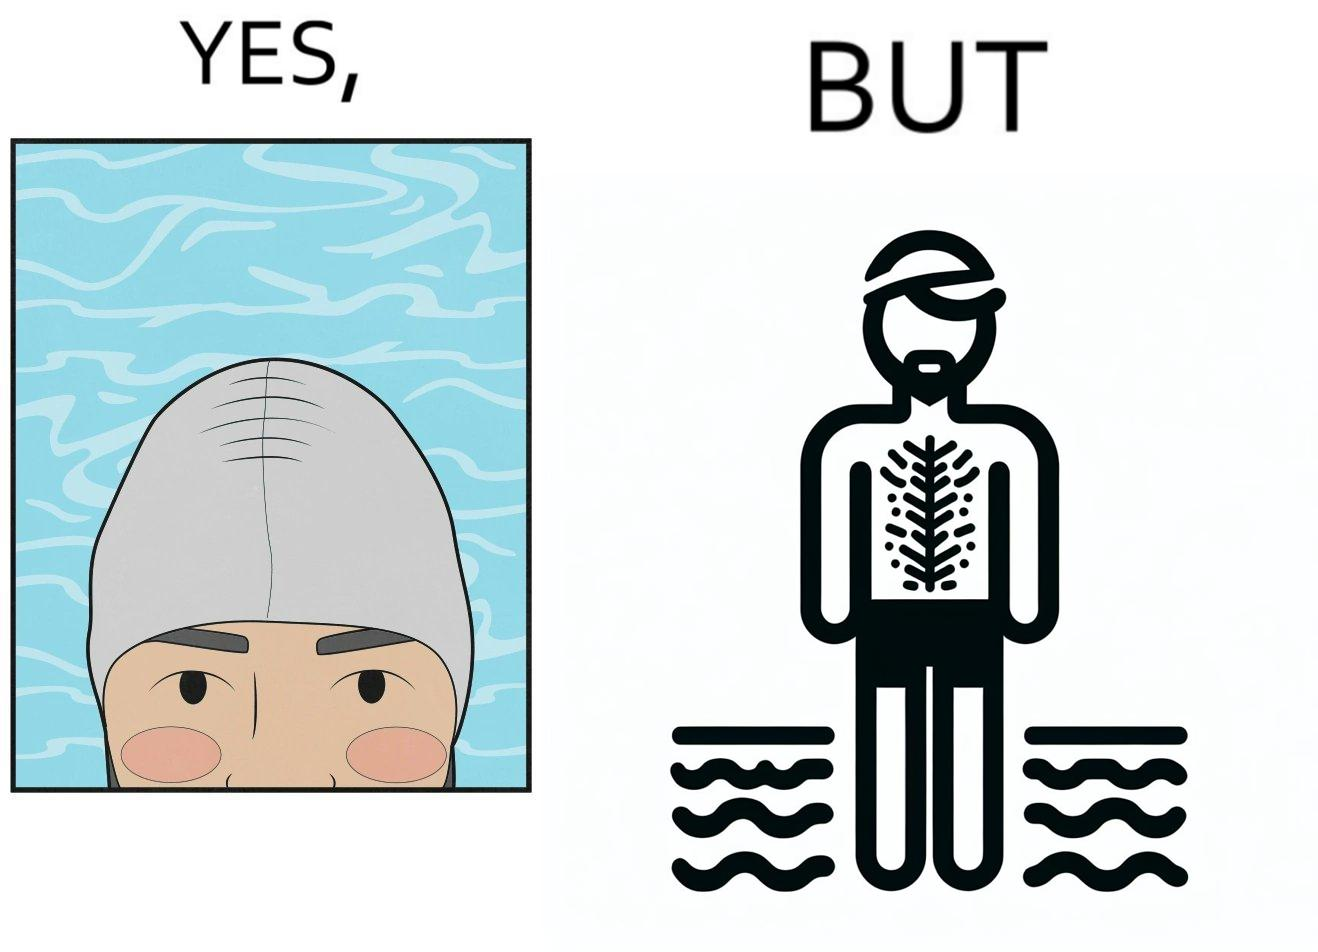Is there satirical content in this image? Yes, this image is satirical. 